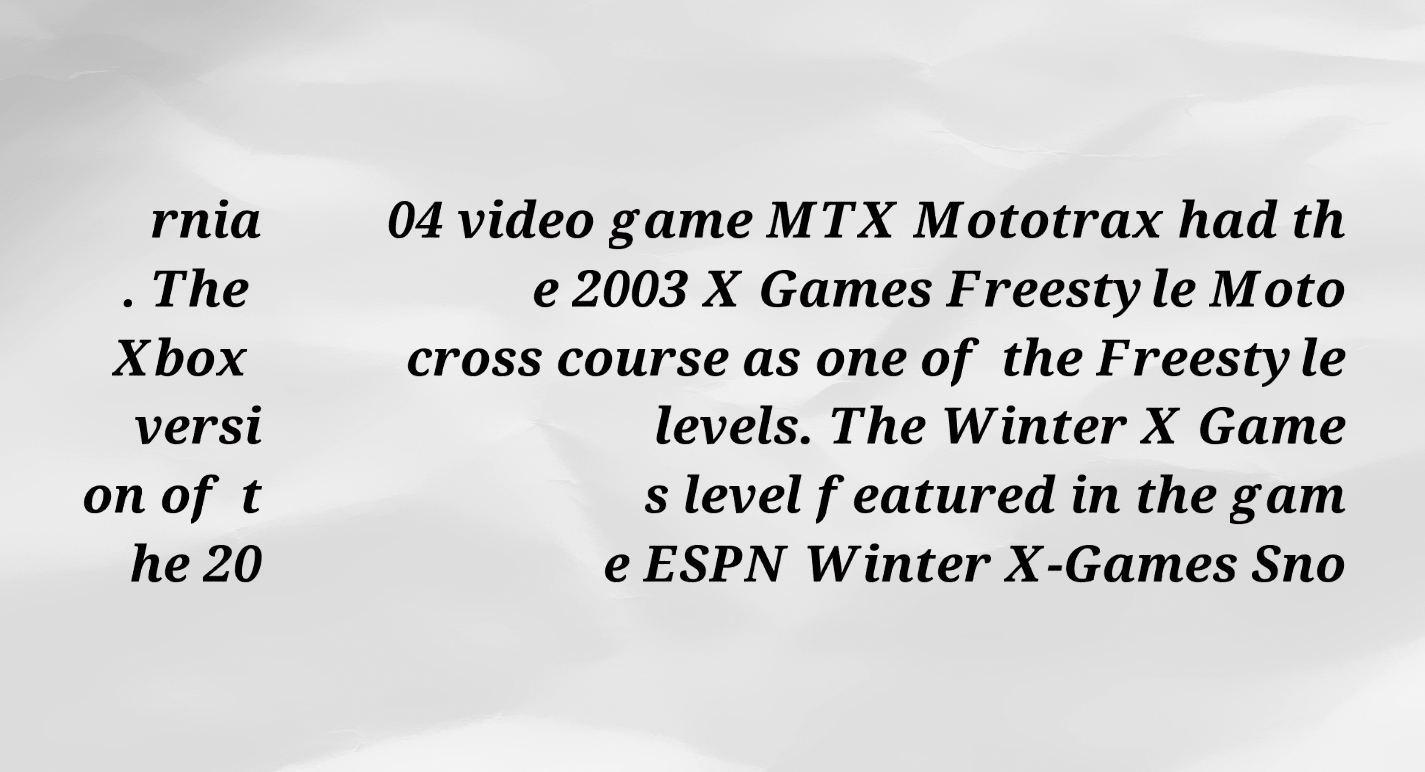Could you extract and type out the text from this image? rnia . The Xbox versi on of t he 20 04 video game MTX Mototrax had th e 2003 X Games Freestyle Moto cross course as one of the Freestyle levels. The Winter X Game s level featured in the gam e ESPN Winter X-Games Sno 